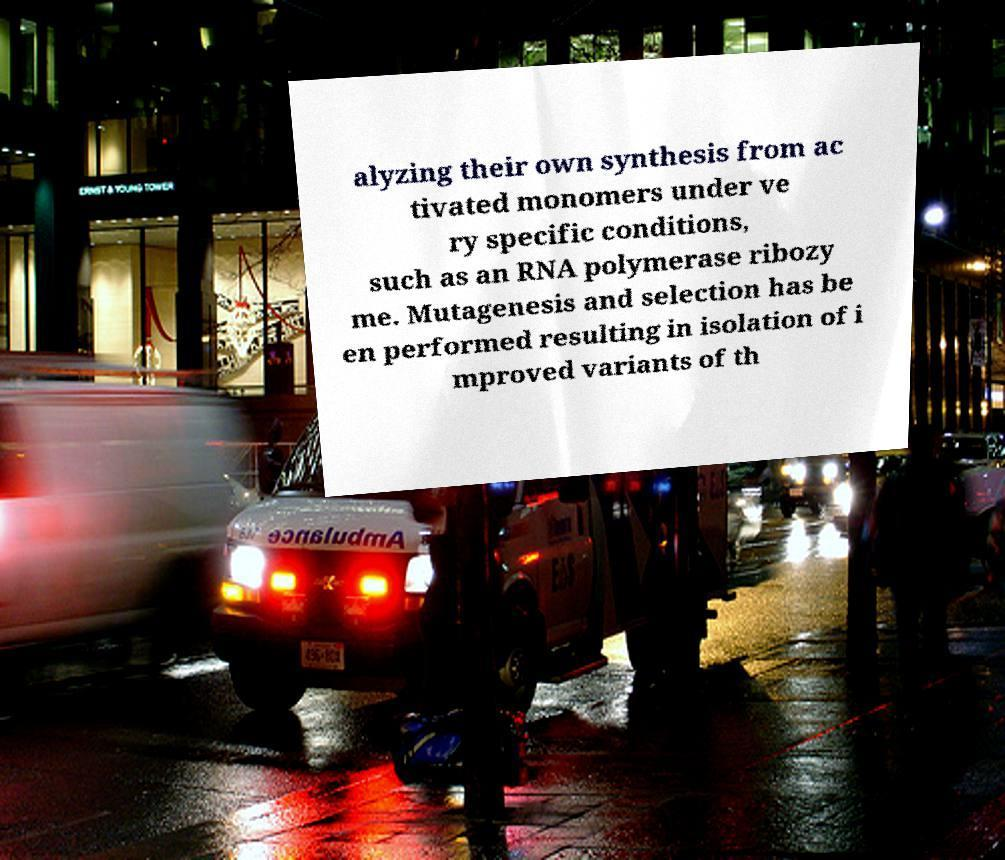Could you extract and type out the text from this image? alyzing their own synthesis from ac tivated monomers under ve ry specific conditions, such as an RNA polymerase ribozy me. Mutagenesis and selection has be en performed resulting in isolation of i mproved variants of th 